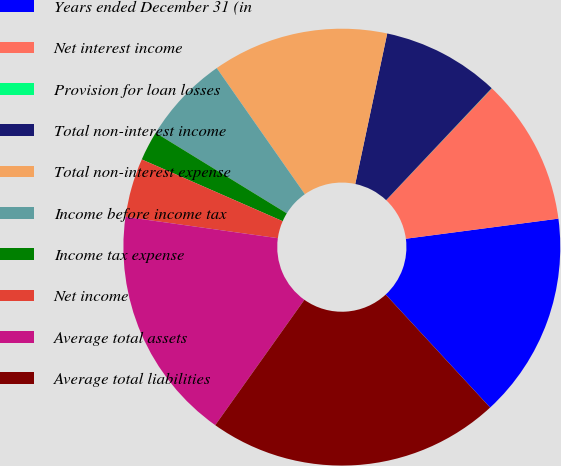<chart> <loc_0><loc_0><loc_500><loc_500><pie_chart><fcel>Years ended December 31 (in<fcel>Net interest income<fcel>Provision for loan losses<fcel>Total non-interest income<fcel>Total non-interest expense<fcel>Income before income tax<fcel>Income tax expense<fcel>Net income<fcel>Average total assets<fcel>Average total liabilities<nl><fcel>15.21%<fcel>10.87%<fcel>0.02%<fcel>8.7%<fcel>13.04%<fcel>6.53%<fcel>2.19%<fcel>4.36%<fcel>17.38%<fcel>21.72%<nl></chart> 